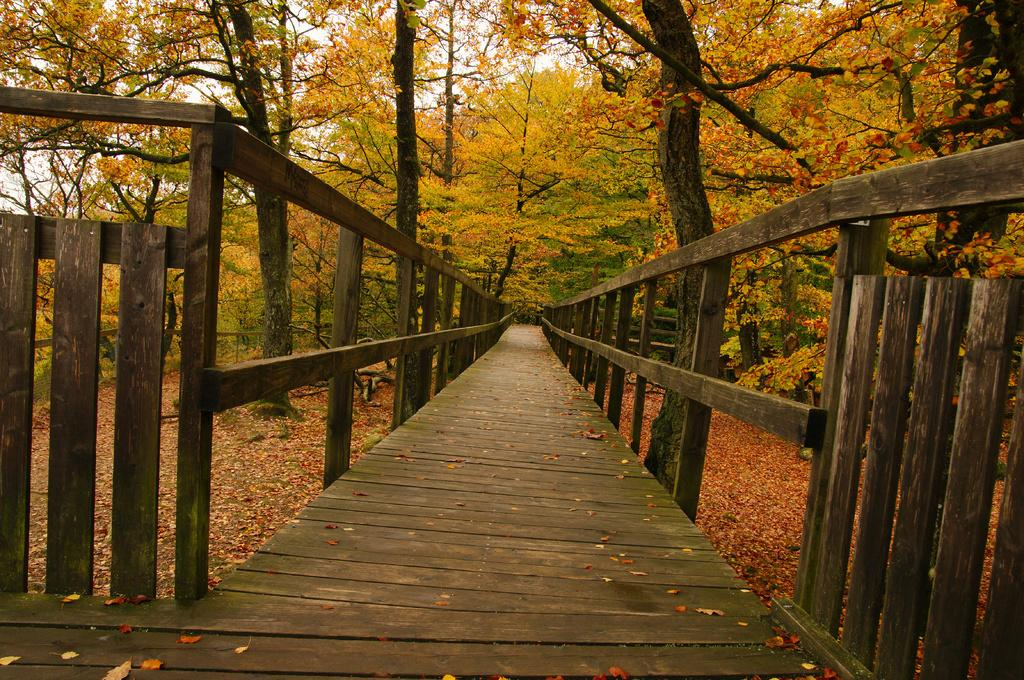What type of fencing is visible in the image? There is a wooden fencing in the image. What kind of path can be seen in the image? There is a wooden path in the image. What type of vegetation is present in the image? There are trees in the image. What colors are the leaves on the trees in the image? The leaves on the trees are yellow and orange in color. What is the color of the sky in the image? The sky appears to be white in color. What is the name of the watch worn by the tree in the image? There is no watch present in the image, and trees do not wear watches. What type of thread is used to connect the leaves on the trees in the image? There is no thread connecting the leaves on the trees in the image; they are naturally attached to the branches. 